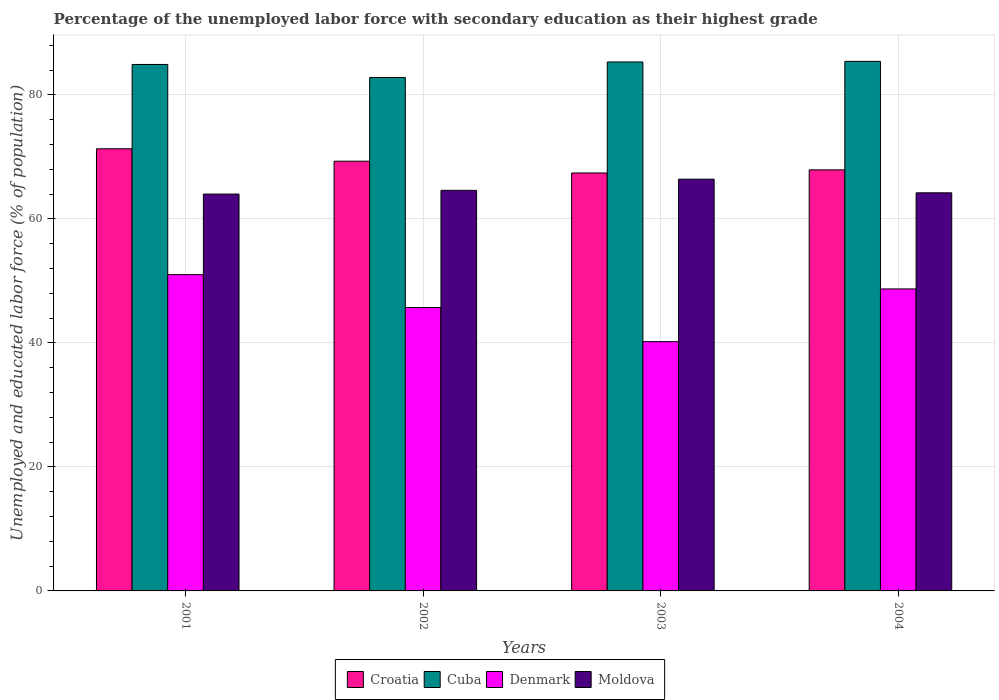How many groups of bars are there?
Provide a succinct answer. 4. How many bars are there on the 3rd tick from the right?
Make the answer very short. 4. In how many cases, is the number of bars for a given year not equal to the number of legend labels?
Give a very brief answer. 0. What is the percentage of the unemployed labor force with secondary education in Denmark in 2004?
Make the answer very short. 48.7. Across all years, what is the minimum percentage of the unemployed labor force with secondary education in Cuba?
Give a very brief answer. 82.8. What is the total percentage of the unemployed labor force with secondary education in Croatia in the graph?
Give a very brief answer. 275.9. What is the difference between the percentage of the unemployed labor force with secondary education in Cuba in 2002 and that in 2004?
Your answer should be compact. -2.6. What is the difference between the percentage of the unemployed labor force with secondary education in Moldova in 2001 and the percentage of the unemployed labor force with secondary education in Cuba in 2002?
Your answer should be very brief. -18.8. What is the average percentage of the unemployed labor force with secondary education in Moldova per year?
Make the answer very short. 64.8. In the year 2004, what is the difference between the percentage of the unemployed labor force with secondary education in Cuba and percentage of the unemployed labor force with secondary education in Croatia?
Your answer should be very brief. 17.5. In how many years, is the percentage of the unemployed labor force with secondary education in Cuba greater than 64 %?
Your answer should be very brief. 4. What is the ratio of the percentage of the unemployed labor force with secondary education in Cuba in 2002 to that in 2004?
Ensure brevity in your answer.  0.97. What is the difference between the highest and the second highest percentage of the unemployed labor force with secondary education in Cuba?
Offer a very short reply. 0.1. What is the difference between the highest and the lowest percentage of the unemployed labor force with secondary education in Cuba?
Offer a very short reply. 2.6. In how many years, is the percentage of the unemployed labor force with secondary education in Moldova greater than the average percentage of the unemployed labor force with secondary education in Moldova taken over all years?
Your answer should be very brief. 1. Is the sum of the percentage of the unemployed labor force with secondary education in Cuba in 2002 and 2004 greater than the maximum percentage of the unemployed labor force with secondary education in Moldova across all years?
Your answer should be compact. Yes. What does the 2nd bar from the left in 2002 represents?
Your response must be concise. Cuba. Is it the case that in every year, the sum of the percentage of the unemployed labor force with secondary education in Denmark and percentage of the unemployed labor force with secondary education in Cuba is greater than the percentage of the unemployed labor force with secondary education in Croatia?
Provide a short and direct response. Yes. Are all the bars in the graph horizontal?
Provide a succinct answer. No. What is the difference between two consecutive major ticks on the Y-axis?
Keep it short and to the point. 20. Does the graph contain any zero values?
Keep it short and to the point. No. Does the graph contain grids?
Make the answer very short. Yes. How are the legend labels stacked?
Your answer should be compact. Horizontal. What is the title of the graph?
Offer a very short reply. Percentage of the unemployed labor force with secondary education as their highest grade. Does "Andorra" appear as one of the legend labels in the graph?
Provide a short and direct response. No. What is the label or title of the X-axis?
Offer a very short reply. Years. What is the label or title of the Y-axis?
Offer a terse response. Unemployed and educated labor force (% of population). What is the Unemployed and educated labor force (% of population) of Croatia in 2001?
Offer a very short reply. 71.3. What is the Unemployed and educated labor force (% of population) of Cuba in 2001?
Offer a terse response. 84.9. What is the Unemployed and educated labor force (% of population) in Denmark in 2001?
Your response must be concise. 51. What is the Unemployed and educated labor force (% of population) of Moldova in 2001?
Keep it short and to the point. 64. What is the Unemployed and educated labor force (% of population) of Croatia in 2002?
Your response must be concise. 69.3. What is the Unemployed and educated labor force (% of population) of Cuba in 2002?
Offer a terse response. 82.8. What is the Unemployed and educated labor force (% of population) in Denmark in 2002?
Provide a succinct answer. 45.7. What is the Unemployed and educated labor force (% of population) of Moldova in 2002?
Provide a succinct answer. 64.6. What is the Unemployed and educated labor force (% of population) in Croatia in 2003?
Give a very brief answer. 67.4. What is the Unemployed and educated labor force (% of population) in Cuba in 2003?
Your answer should be compact. 85.3. What is the Unemployed and educated labor force (% of population) of Denmark in 2003?
Give a very brief answer. 40.2. What is the Unemployed and educated labor force (% of population) in Moldova in 2003?
Keep it short and to the point. 66.4. What is the Unemployed and educated labor force (% of population) in Croatia in 2004?
Your answer should be very brief. 67.9. What is the Unemployed and educated labor force (% of population) of Cuba in 2004?
Provide a succinct answer. 85.4. What is the Unemployed and educated labor force (% of population) in Denmark in 2004?
Make the answer very short. 48.7. What is the Unemployed and educated labor force (% of population) in Moldova in 2004?
Offer a terse response. 64.2. Across all years, what is the maximum Unemployed and educated labor force (% of population) of Croatia?
Offer a very short reply. 71.3. Across all years, what is the maximum Unemployed and educated labor force (% of population) in Cuba?
Make the answer very short. 85.4. Across all years, what is the maximum Unemployed and educated labor force (% of population) in Moldova?
Provide a short and direct response. 66.4. Across all years, what is the minimum Unemployed and educated labor force (% of population) in Croatia?
Ensure brevity in your answer.  67.4. Across all years, what is the minimum Unemployed and educated labor force (% of population) of Cuba?
Your answer should be very brief. 82.8. Across all years, what is the minimum Unemployed and educated labor force (% of population) in Denmark?
Provide a short and direct response. 40.2. What is the total Unemployed and educated labor force (% of population) of Croatia in the graph?
Your answer should be compact. 275.9. What is the total Unemployed and educated labor force (% of population) of Cuba in the graph?
Ensure brevity in your answer.  338.4. What is the total Unemployed and educated labor force (% of population) in Denmark in the graph?
Your answer should be compact. 185.6. What is the total Unemployed and educated labor force (% of population) in Moldova in the graph?
Your answer should be very brief. 259.2. What is the difference between the Unemployed and educated labor force (% of population) in Croatia in 2001 and that in 2002?
Offer a terse response. 2. What is the difference between the Unemployed and educated labor force (% of population) of Denmark in 2001 and that in 2003?
Make the answer very short. 10.8. What is the difference between the Unemployed and educated labor force (% of population) in Moldova in 2001 and that in 2003?
Give a very brief answer. -2.4. What is the difference between the Unemployed and educated labor force (% of population) in Croatia in 2002 and that in 2003?
Your response must be concise. 1.9. What is the difference between the Unemployed and educated labor force (% of population) in Cuba in 2002 and that in 2003?
Your answer should be compact. -2.5. What is the difference between the Unemployed and educated labor force (% of population) of Denmark in 2002 and that in 2003?
Ensure brevity in your answer.  5.5. What is the difference between the Unemployed and educated labor force (% of population) of Croatia in 2002 and that in 2004?
Provide a succinct answer. 1.4. What is the difference between the Unemployed and educated labor force (% of population) in Cuba in 2003 and that in 2004?
Keep it short and to the point. -0.1. What is the difference between the Unemployed and educated labor force (% of population) of Moldova in 2003 and that in 2004?
Make the answer very short. 2.2. What is the difference between the Unemployed and educated labor force (% of population) in Croatia in 2001 and the Unemployed and educated labor force (% of population) in Cuba in 2002?
Your answer should be very brief. -11.5. What is the difference between the Unemployed and educated labor force (% of population) of Croatia in 2001 and the Unemployed and educated labor force (% of population) of Denmark in 2002?
Offer a terse response. 25.6. What is the difference between the Unemployed and educated labor force (% of population) in Cuba in 2001 and the Unemployed and educated labor force (% of population) in Denmark in 2002?
Provide a short and direct response. 39.2. What is the difference between the Unemployed and educated labor force (% of population) of Cuba in 2001 and the Unemployed and educated labor force (% of population) of Moldova in 2002?
Ensure brevity in your answer.  20.3. What is the difference between the Unemployed and educated labor force (% of population) of Croatia in 2001 and the Unemployed and educated labor force (% of population) of Denmark in 2003?
Provide a succinct answer. 31.1. What is the difference between the Unemployed and educated labor force (% of population) of Croatia in 2001 and the Unemployed and educated labor force (% of population) of Moldova in 2003?
Your response must be concise. 4.9. What is the difference between the Unemployed and educated labor force (% of population) of Cuba in 2001 and the Unemployed and educated labor force (% of population) of Denmark in 2003?
Ensure brevity in your answer.  44.7. What is the difference between the Unemployed and educated labor force (% of population) of Denmark in 2001 and the Unemployed and educated labor force (% of population) of Moldova in 2003?
Offer a terse response. -15.4. What is the difference between the Unemployed and educated labor force (% of population) of Croatia in 2001 and the Unemployed and educated labor force (% of population) of Cuba in 2004?
Ensure brevity in your answer.  -14.1. What is the difference between the Unemployed and educated labor force (% of population) of Croatia in 2001 and the Unemployed and educated labor force (% of population) of Denmark in 2004?
Give a very brief answer. 22.6. What is the difference between the Unemployed and educated labor force (% of population) in Croatia in 2001 and the Unemployed and educated labor force (% of population) in Moldova in 2004?
Ensure brevity in your answer.  7.1. What is the difference between the Unemployed and educated labor force (% of population) of Cuba in 2001 and the Unemployed and educated labor force (% of population) of Denmark in 2004?
Make the answer very short. 36.2. What is the difference between the Unemployed and educated labor force (% of population) of Cuba in 2001 and the Unemployed and educated labor force (% of population) of Moldova in 2004?
Your answer should be very brief. 20.7. What is the difference between the Unemployed and educated labor force (% of population) in Croatia in 2002 and the Unemployed and educated labor force (% of population) in Cuba in 2003?
Keep it short and to the point. -16. What is the difference between the Unemployed and educated labor force (% of population) in Croatia in 2002 and the Unemployed and educated labor force (% of population) in Denmark in 2003?
Offer a terse response. 29.1. What is the difference between the Unemployed and educated labor force (% of population) of Cuba in 2002 and the Unemployed and educated labor force (% of population) of Denmark in 2003?
Provide a short and direct response. 42.6. What is the difference between the Unemployed and educated labor force (% of population) of Cuba in 2002 and the Unemployed and educated labor force (% of population) of Moldova in 2003?
Provide a short and direct response. 16.4. What is the difference between the Unemployed and educated labor force (% of population) of Denmark in 2002 and the Unemployed and educated labor force (% of population) of Moldova in 2003?
Provide a succinct answer. -20.7. What is the difference between the Unemployed and educated labor force (% of population) in Croatia in 2002 and the Unemployed and educated labor force (% of population) in Cuba in 2004?
Give a very brief answer. -16.1. What is the difference between the Unemployed and educated labor force (% of population) in Croatia in 2002 and the Unemployed and educated labor force (% of population) in Denmark in 2004?
Your answer should be very brief. 20.6. What is the difference between the Unemployed and educated labor force (% of population) in Croatia in 2002 and the Unemployed and educated labor force (% of population) in Moldova in 2004?
Offer a terse response. 5.1. What is the difference between the Unemployed and educated labor force (% of population) in Cuba in 2002 and the Unemployed and educated labor force (% of population) in Denmark in 2004?
Offer a very short reply. 34.1. What is the difference between the Unemployed and educated labor force (% of population) of Cuba in 2002 and the Unemployed and educated labor force (% of population) of Moldova in 2004?
Your answer should be compact. 18.6. What is the difference between the Unemployed and educated labor force (% of population) of Denmark in 2002 and the Unemployed and educated labor force (% of population) of Moldova in 2004?
Your response must be concise. -18.5. What is the difference between the Unemployed and educated labor force (% of population) in Croatia in 2003 and the Unemployed and educated labor force (% of population) in Denmark in 2004?
Keep it short and to the point. 18.7. What is the difference between the Unemployed and educated labor force (% of population) in Cuba in 2003 and the Unemployed and educated labor force (% of population) in Denmark in 2004?
Your answer should be compact. 36.6. What is the difference between the Unemployed and educated labor force (% of population) of Cuba in 2003 and the Unemployed and educated labor force (% of population) of Moldova in 2004?
Ensure brevity in your answer.  21.1. What is the average Unemployed and educated labor force (% of population) in Croatia per year?
Ensure brevity in your answer.  68.97. What is the average Unemployed and educated labor force (% of population) of Cuba per year?
Your answer should be compact. 84.6. What is the average Unemployed and educated labor force (% of population) of Denmark per year?
Provide a short and direct response. 46.4. What is the average Unemployed and educated labor force (% of population) in Moldova per year?
Ensure brevity in your answer.  64.8. In the year 2001, what is the difference between the Unemployed and educated labor force (% of population) of Croatia and Unemployed and educated labor force (% of population) of Cuba?
Make the answer very short. -13.6. In the year 2001, what is the difference between the Unemployed and educated labor force (% of population) of Croatia and Unemployed and educated labor force (% of population) of Denmark?
Offer a terse response. 20.3. In the year 2001, what is the difference between the Unemployed and educated labor force (% of population) in Cuba and Unemployed and educated labor force (% of population) in Denmark?
Your answer should be compact. 33.9. In the year 2001, what is the difference between the Unemployed and educated labor force (% of population) in Cuba and Unemployed and educated labor force (% of population) in Moldova?
Ensure brevity in your answer.  20.9. In the year 2001, what is the difference between the Unemployed and educated labor force (% of population) in Denmark and Unemployed and educated labor force (% of population) in Moldova?
Your answer should be very brief. -13. In the year 2002, what is the difference between the Unemployed and educated labor force (% of population) in Croatia and Unemployed and educated labor force (% of population) in Cuba?
Provide a short and direct response. -13.5. In the year 2002, what is the difference between the Unemployed and educated labor force (% of population) of Croatia and Unemployed and educated labor force (% of population) of Denmark?
Offer a terse response. 23.6. In the year 2002, what is the difference between the Unemployed and educated labor force (% of population) in Croatia and Unemployed and educated labor force (% of population) in Moldova?
Your answer should be very brief. 4.7. In the year 2002, what is the difference between the Unemployed and educated labor force (% of population) of Cuba and Unemployed and educated labor force (% of population) of Denmark?
Ensure brevity in your answer.  37.1. In the year 2002, what is the difference between the Unemployed and educated labor force (% of population) in Denmark and Unemployed and educated labor force (% of population) in Moldova?
Make the answer very short. -18.9. In the year 2003, what is the difference between the Unemployed and educated labor force (% of population) in Croatia and Unemployed and educated labor force (% of population) in Cuba?
Make the answer very short. -17.9. In the year 2003, what is the difference between the Unemployed and educated labor force (% of population) of Croatia and Unemployed and educated labor force (% of population) of Denmark?
Your response must be concise. 27.2. In the year 2003, what is the difference between the Unemployed and educated labor force (% of population) in Cuba and Unemployed and educated labor force (% of population) in Denmark?
Make the answer very short. 45.1. In the year 2003, what is the difference between the Unemployed and educated labor force (% of population) of Denmark and Unemployed and educated labor force (% of population) of Moldova?
Make the answer very short. -26.2. In the year 2004, what is the difference between the Unemployed and educated labor force (% of population) in Croatia and Unemployed and educated labor force (% of population) in Cuba?
Your response must be concise. -17.5. In the year 2004, what is the difference between the Unemployed and educated labor force (% of population) of Croatia and Unemployed and educated labor force (% of population) of Moldova?
Your answer should be very brief. 3.7. In the year 2004, what is the difference between the Unemployed and educated labor force (% of population) of Cuba and Unemployed and educated labor force (% of population) of Denmark?
Keep it short and to the point. 36.7. In the year 2004, what is the difference between the Unemployed and educated labor force (% of population) in Cuba and Unemployed and educated labor force (% of population) in Moldova?
Make the answer very short. 21.2. In the year 2004, what is the difference between the Unemployed and educated labor force (% of population) in Denmark and Unemployed and educated labor force (% of population) in Moldova?
Your answer should be very brief. -15.5. What is the ratio of the Unemployed and educated labor force (% of population) in Croatia in 2001 to that in 2002?
Ensure brevity in your answer.  1.03. What is the ratio of the Unemployed and educated labor force (% of population) of Cuba in 2001 to that in 2002?
Your response must be concise. 1.03. What is the ratio of the Unemployed and educated labor force (% of population) of Denmark in 2001 to that in 2002?
Make the answer very short. 1.12. What is the ratio of the Unemployed and educated labor force (% of population) of Croatia in 2001 to that in 2003?
Your answer should be very brief. 1.06. What is the ratio of the Unemployed and educated labor force (% of population) in Denmark in 2001 to that in 2003?
Ensure brevity in your answer.  1.27. What is the ratio of the Unemployed and educated labor force (% of population) in Moldova in 2001 to that in 2003?
Make the answer very short. 0.96. What is the ratio of the Unemployed and educated labor force (% of population) in Croatia in 2001 to that in 2004?
Provide a short and direct response. 1.05. What is the ratio of the Unemployed and educated labor force (% of population) in Denmark in 2001 to that in 2004?
Make the answer very short. 1.05. What is the ratio of the Unemployed and educated labor force (% of population) of Croatia in 2002 to that in 2003?
Make the answer very short. 1.03. What is the ratio of the Unemployed and educated labor force (% of population) of Cuba in 2002 to that in 2003?
Make the answer very short. 0.97. What is the ratio of the Unemployed and educated labor force (% of population) of Denmark in 2002 to that in 2003?
Provide a short and direct response. 1.14. What is the ratio of the Unemployed and educated labor force (% of population) in Moldova in 2002 to that in 2003?
Provide a succinct answer. 0.97. What is the ratio of the Unemployed and educated labor force (% of population) in Croatia in 2002 to that in 2004?
Ensure brevity in your answer.  1.02. What is the ratio of the Unemployed and educated labor force (% of population) of Cuba in 2002 to that in 2004?
Provide a short and direct response. 0.97. What is the ratio of the Unemployed and educated labor force (% of population) in Denmark in 2002 to that in 2004?
Offer a very short reply. 0.94. What is the ratio of the Unemployed and educated labor force (% of population) in Moldova in 2002 to that in 2004?
Your answer should be very brief. 1.01. What is the ratio of the Unemployed and educated labor force (% of population) in Croatia in 2003 to that in 2004?
Offer a very short reply. 0.99. What is the ratio of the Unemployed and educated labor force (% of population) of Cuba in 2003 to that in 2004?
Offer a terse response. 1. What is the ratio of the Unemployed and educated labor force (% of population) in Denmark in 2003 to that in 2004?
Provide a short and direct response. 0.83. What is the ratio of the Unemployed and educated labor force (% of population) of Moldova in 2003 to that in 2004?
Ensure brevity in your answer.  1.03. What is the difference between the highest and the second highest Unemployed and educated labor force (% of population) of Croatia?
Give a very brief answer. 2. What is the difference between the highest and the second highest Unemployed and educated labor force (% of population) of Cuba?
Make the answer very short. 0.1. What is the difference between the highest and the second highest Unemployed and educated labor force (% of population) of Moldova?
Your response must be concise. 1.8. What is the difference between the highest and the lowest Unemployed and educated labor force (% of population) in Cuba?
Provide a succinct answer. 2.6. 